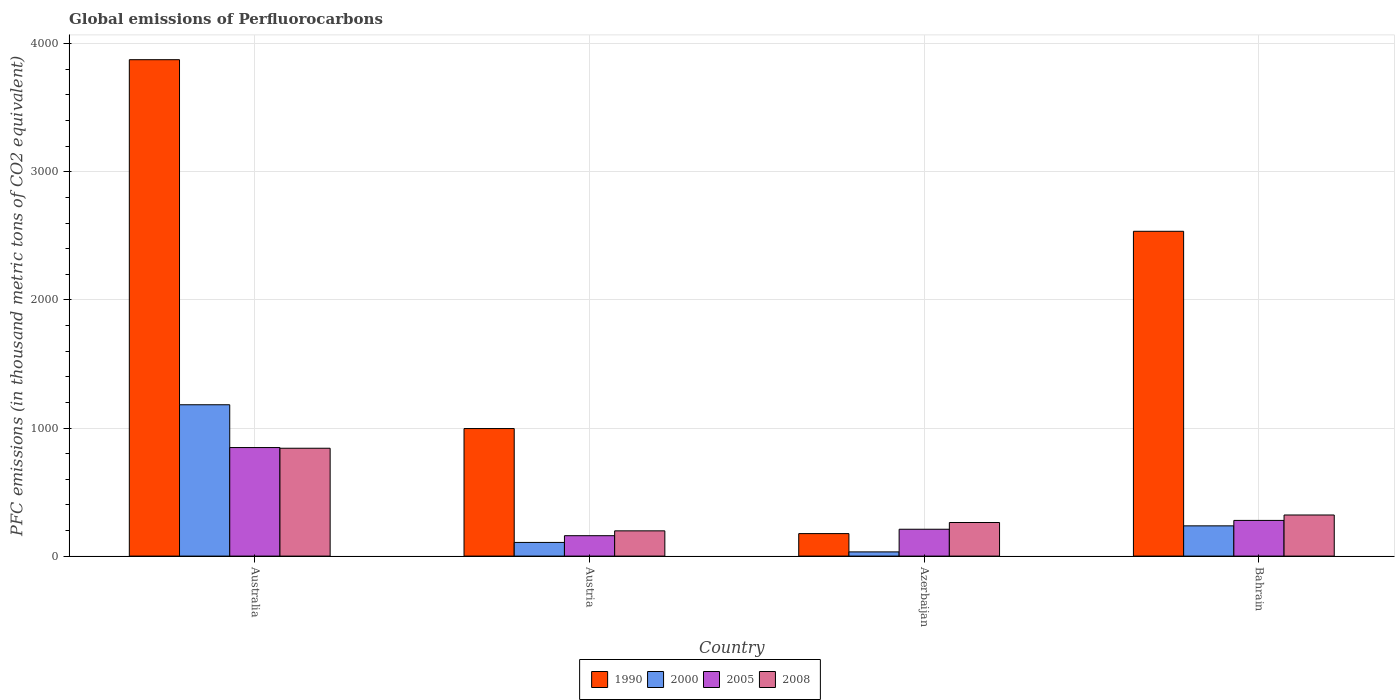How many different coloured bars are there?
Ensure brevity in your answer.  4. What is the label of the 3rd group of bars from the left?
Give a very brief answer. Azerbaijan. What is the global emissions of Perfluorocarbons in 2000 in Austria?
Provide a short and direct response. 106.7. Across all countries, what is the maximum global emissions of Perfluorocarbons in 2008?
Keep it short and to the point. 842. Across all countries, what is the minimum global emissions of Perfluorocarbons in 2005?
Your answer should be very brief. 159.3. In which country was the global emissions of Perfluorocarbons in 1990 minimum?
Your answer should be very brief. Azerbaijan. What is the total global emissions of Perfluorocarbons in 2008 in the graph?
Provide a short and direct response. 1622.2. What is the difference between the global emissions of Perfluorocarbons in 2005 in Azerbaijan and that in Bahrain?
Provide a succinct answer. -68.9. What is the difference between the global emissions of Perfluorocarbons in 2005 in Bahrain and the global emissions of Perfluorocarbons in 2000 in Azerbaijan?
Provide a short and direct response. 245.8. What is the average global emissions of Perfluorocarbons in 2008 per country?
Make the answer very short. 405.55. What is the difference between the global emissions of Perfluorocarbons of/in 2000 and global emissions of Perfluorocarbons of/in 1990 in Azerbaijan?
Your answer should be very brief. -142.8. In how many countries, is the global emissions of Perfluorocarbons in 2008 greater than 1200 thousand metric tons?
Your answer should be compact. 0. What is the ratio of the global emissions of Perfluorocarbons in 2005 in Austria to that in Bahrain?
Make the answer very short. 0.57. Is the global emissions of Perfluorocarbons in 1990 in Australia less than that in Azerbaijan?
Your response must be concise. No. What is the difference between the highest and the second highest global emissions of Perfluorocarbons in 2005?
Provide a short and direct response. -68.9. What is the difference between the highest and the lowest global emissions of Perfluorocarbons in 2005?
Provide a succinct answer. 688.1. In how many countries, is the global emissions of Perfluorocarbons in 1990 greater than the average global emissions of Perfluorocarbons in 1990 taken over all countries?
Your answer should be very brief. 2. What does the 2nd bar from the left in Australia represents?
Offer a very short reply. 2000. What does the 3rd bar from the right in Azerbaijan represents?
Provide a succinct answer. 2000. Is it the case that in every country, the sum of the global emissions of Perfluorocarbons in 2000 and global emissions of Perfluorocarbons in 1990 is greater than the global emissions of Perfluorocarbons in 2005?
Provide a succinct answer. No. How many bars are there?
Offer a terse response. 16. Are all the bars in the graph horizontal?
Offer a very short reply. No. How many countries are there in the graph?
Offer a very short reply. 4. Are the values on the major ticks of Y-axis written in scientific E-notation?
Offer a terse response. No. Does the graph contain any zero values?
Provide a short and direct response. No. Where does the legend appear in the graph?
Ensure brevity in your answer.  Bottom center. What is the title of the graph?
Your answer should be compact. Global emissions of Perfluorocarbons. What is the label or title of the Y-axis?
Offer a terse response. PFC emissions (in thousand metric tons of CO2 equivalent). What is the PFC emissions (in thousand metric tons of CO2 equivalent) in 1990 in Australia?
Offer a terse response. 3875.2. What is the PFC emissions (in thousand metric tons of CO2 equivalent) in 2000 in Australia?
Make the answer very short. 1181.4. What is the PFC emissions (in thousand metric tons of CO2 equivalent) of 2005 in Australia?
Your response must be concise. 847.4. What is the PFC emissions (in thousand metric tons of CO2 equivalent) of 2008 in Australia?
Your answer should be compact. 842. What is the PFC emissions (in thousand metric tons of CO2 equivalent) in 1990 in Austria?
Keep it short and to the point. 995.7. What is the PFC emissions (in thousand metric tons of CO2 equivalent) of 2000 in Austria?
Offer a terse response. 106.7. What is the PFC emissions (in thousand metric tons of CO2 equivalent) of 2005 in Austria?
Provide a short and direct response. 159.3. What is the PFC emissions (in thousand metric tons of CO2 equivalent) of 2008 in Austria?
Keep it short and to the point. 197.1. What is the PFC emissions (in thousand metric tons of CO2 equivalent) of 1990 in Azerbaijan?
Offer a very short reply. 175.6. What is the PFC emissions (in thousand metric tons of CO2 equivalent) in 2000 in Azerbaijan?
Give a very brief answer. 32.8. What is the PFC emissions (in thousand metric tons of CO2 equivalent) of 2005 in Azerbaijan?
Ensure brevity in your answer.  209.7. What is the PFC emissions (in thousand metric tons of CO2 equivalent) of 2008 in Azerbaijan?
Provide a succinct answer. 262.2. What is the PFC emissions (in thousand metric tons of CO2 equivalent) in 1990 in Bahrain?
Keep it short and to the point. 2535.7. What is the PFC emissions (in thousand metric tons of CO2 equivalent) of 2000 in Bahrain?
Give a very brief answer. 236.1. What is the PFC emissions (in thousand metric tons of CO2 equivalent) of 2005 in Bahrain?
Offer a terse response. 278.6. What is the PFC emissions (in thousand metric tons of CO2 equivalent) of 2008 in Bahrain?
Provide a short and direct response. 320.9. Across all countries, what is the maximum PFC emissions (in thousand metric tons of CO2 equivalent) in 1990?
Your answer should be very brief. 3875.2. Across all countries, what is the maximum PFC emissions (in thousand metric tons of CO2 equivalent) of 2000?
Make the answer very short. 1181.4. Across all countries, what is the maximum PFC emissions (in thousand metric tons of CO2 equivalent) of 2005?
Your response must be concise. 847.4. Across all countries, what is the maximum PFC emissions (in thousand metric tons of CO2 equivalent) in 2008?
Offer a terse response. 842. Across all countries, what is the minimum PFC emissions (in thousand metric tons of CO2 equivalent) in 1990?
Make the answer very short. 175.6. Across all countries, what is the minimum PFC emissions (in thousand metric tons of CO2 equivalent) of 2000?
Ensure brevity in your answer.  32.8. Across all countries, what is the minimum PFC emissions (in thousand metric tons of CO2 equivalent) of 2005?
Make the answer very short. 159.3. Across all countries, what is the minimum PFC emissions (in thousand metric tons of CO2 equivalent) in 2008?
Make the answer very short. 197.1. What is the total PFC emissions (in thousand metric tons of CO2 equivalent) in 1990 in the graph?
Ensure brevity in your answer.  7582.2. What is the total PFC emissions (in thousand metric tons of CO2 equivalent) of 2000 in the graph?
Provide a succinct answer. 1557. What is the total PFC emissions (in thousand metric tons of CO2 equivalent) of 2005 in the graph?
Offer a very short reply. 1495. What is the total PFC emissions (in thousand metric tons of CO2 equivalent) of 2008 in the graph?
Your answer should be very brief. 1622.2. What is the difference between the PFC emissions (in thousand metric tons of CO2 equivalent) in 1990 in Australia and that in Austria?
Offer a very short reply. 2879.5. What is the difference between the PFC emissions (in thousand metric tons of CO2 equivalent) of 2000 in Australia and that in Austria?
Give a very brief answer. 1074.7. What is the difference between the PFC emissions (in thousand metric tons of CO2 equivalent) of 2005 in Australia and that in Austria?
Ensure brevity in your answer.  688.1. What is the difference between the PFC emissions (in thousand metric tons of CO2 equivalent) of 2008 in Australia and that in Austria?
Offer a very short reply. 644.9. What is the difference between the PFC emissions (in thousand metric tons of CO2 equivalent) of 1990 in Australia and that in Azerbaijan?
Ensure brevity in your answer.  3699.6. What is the difference between the PFC emissions (in thousand metric tons of CO2 equivalent) in 2000 in Australia and that in Azerbaijan?
Your answer should be compact. 1148.6. What is the difference between the PFC emissions (in thousand metric tons of CO2 equivalent) in 2005 in Australia and that in Azerbaijan?
Your answer should be compact. 637.7. What is the difference between the PFC emissions (in thousand metric tons of CO2 equivalent) of 2008 in Australia and that in Azerbaijan?
Give a very brief answer. 579.8. What is the difference between the PFC emissions (in thousand metric tons of CO2 equivalent) in 1990 in Australia and that in Bahrain?
Your answer should be very brief. 1339.5. What is the difference between the PFC emissions (in thousand metric tons of CO2 equivalent) in 2000 in Australia and that in Bahrain?
Give a very brief answer. 945.3. What is the difference between the PFC emissions (in thousand metric tons of CO2 equivalent) in 2005 in Australia and that in Bahrain?
Offer a terse response. 568.8. What is the difference between the PFC emissions (in thousand metric tons of CO2 equivalent) of 2008 in Australia and that in Bahrain?
Provide a short and direct response. 521.1. What is the difference between the PFC emissions (in thousand metric tons of CO2 equivalent) of 1990 in Austria and that in Azerbaijan?
Your response must be concise. 820.1. What is the difference between the PFC emissions (in thousand metric tons of CO2 equivalent) of 2000 in Austria and that in Azerbaijan?
Your response must be concise. 73.9. What is the difference between the PFC emissions (in thousand metric tons of CO2 equivalent) in 2005 in Austria and that in Azerbaijan?
Keep it short and to the point. -50.4. What is the difference between the PFC emissions (in thousand metric tons of CO2 equivalent) in 2008 in Austria and that in Azerbaijan?
Offer a terse response. -65.1. What is the difference between the PFC emissions (in thousand metric tons of CO2 equivalent) of 1990 in Austria and that in Bahrain?
Ensure brevity in your answer.  -1540. What is the difference between the PFC emissions (in thousand metric tons of CO2 equivalent) in 2000 in Austria and that in Bahrain?
Your answer should be very brief. -129.4. What is the difference between the PFC emissions (in thousand metric tons of CO2 equivalent) in 2005 in Austria and that in Bahrain?
Provide a short and direct response. -119.3. What is the difference between the PFC emissions (in thousand metric tons of CO2 equivalent) of 2008 in Austria and that in Bahrain?
Your answer should be very brief. -123.8. What is the difference between the PFC emissions (in thousand metric tons of CO2 equivalent) of 1990 in Azerbaijan and that in Bahrain?
Provide a short and direct response. -2360.1. What is the difference between the PFC emissions (in thousand metric tons of CO2 equivalent) of 2000 in Azerbaijan and that in Bahrain?
Give a very brief answer. -203.3. What is the difference between the PFC emissions (in thousand metric tons of CO2 equivalent) in 2005 in Azerbaijan and that in Bahrain?
Keep it short and to the point. -68.9. What is the difference between the PFC emissions (in thousand metric tons of CO2 equivalent) in 2008 in Azerbaijan and that in Bahrain?
Keep it short and to the point. -58.7. What is the difference between the PFC emissions (in thousand metric tons of CO2 equivalent) in 1990 in Australia and the PFC emissions (in thousand metric tons of CO2 equivalent) in 2000 in Austria?
Your response must be concise. 3768.5. What is the difference between the PFC emissions (in thousand metric tons of CO2 equivalent) in 1990 in Australia and the PFC emissions (in thousand metric tons of CO2 equivalent) in 2005 in Austria?
Your response must be concise. 3715.9. What is the difference between the PFC emissions (in thousand metric tons of CO2 equivalent) of 1990 in Australia and the PFC emissions (in thousand metric tons of CO2 equivalent) of 2008 in Austria?
Offer a terse response. 3678.1. What is the difference between the PFC emissions (in thousand metric tons of CO2 equivalent) of 2000 in Australia and the PFC emissions (in thousand metric tons of CO2 equivalent) of 2005 in Austria?
Your answer should be very brief. 1022.1. What is the difference between the PFC emissions (in thousand metric tons of CO2 equivalent) in 2000 in Australia and the PFC emissions (in thousand metric tons of CO2 equivalent) in 2008 in Austria?
Your answer should be compact. 984.3. What is the difference between the PFC emissions (in thousand metric tons of CO2 equivalent) of 2005 in Australia and the PFC emissions (in thousand metric tons of CO2 equivalent) of 2008 in Austria?
Keep it short and to the point. 650.3. What is the difference between the PFC emissions (in thousand metric tons of CO2 equivalent) of 1990 in Australia and the PFC emissions (in thousand metric tons of CO2 equivalent) of 2000 in Azerbaijan?
Offer a very short reply. 3842.4. What is the difference between the PFC emissions (in thousand metric tons of CO2 equivalent) in 1990 in Australia and the PFC emissions (in thousand metric tons of CO2 equivalent) in 2005 in Azerbaijan?
Your response must be concise. 3665.5. What is the difference between the PFC emissions (in thousand metric tons of CO2 equivalent) of 1990 in Australia and the PFC emissions (in thousand metric tons of CO2 equivalent) of 2008 in Azerbaijan?
Keep it short and to the point. 3613. What is the difference between the PFC emissions (in thousand metric tons of CO2 equivalent) of 2000 in Australia and the PFC emissions (in thousand metric tons of CO2 equivalent) of 2005 in Azerbaijan?
Your answer should be compact. 971.7. What is the difference between the PFC emissions (in thousand metric tons of CO2 equivalent) of 2000 in Australia and the PFC emissions (in thousand metric tons of CO2 equivalent) of 2008 in Azerbaijan?
Provide a succinct answer. 919.2. What is the difference between the PFC emissions (in thousand metric tons of CO2 equivalent) in 2005 in Australia and the PFC emissions (in thousand metric tons of CO2 equivalent) in 2008 in Azerbaijan?
Make the answer very short. 585.2. What is the difference between the PFC emissions (in thousand metric tons of CO2 equivalent) in 1990 in Australia and the PFC emissions (in thousand metric tons of CO2 equivalent) in 2000 in Bahrain?
Your response must be concise. 3639.1. What is the difference between the PFC emissions (in thousand metric tons of CO2 equivalent) in 1990 in Australia and the PFC emissions (in thousand metric tons of CO2 equivalent) in 2005 in Bahrain?
Offer a terse response. 3596.6. What is the difference between the PFC emissions (in thousand metric tons of CO2 equivalent) in 1990 in Australia and the PFC emissions (in thousand metric tons of CO2 equivalent) in 2008 in Bahrain?
Give a very brief answer. 3554.3. What is the difference between the PFC emissions (in thousand metric tons of CO2 equivalent) in 2000 in Australia and the PFC emissions (in thousand metric tons of CO2 equivalent) in 2005 in Bahrain?
Give a very brief answer. 902.8. What is the difference between the PFC emissions (in thousand metric tons of CO2 equivalent) in 2000 in Australia and the PFC emissions (in thousand metric tons of CO2 equivalent) in 2008 in Bahrain?
Provide a succinct answer. 860.5. What is the difference between the PFC emissions (in thousand metric tons of CO2 equivalent) in 2005 in Australia and the PFC emissions (in thousand metric tons of CO2 equivalent) in 2008 in Bahrain?
Your answer should be very brief. 526.5. What is the difference between the PFC emissions (in thousand metric tons of CO2 equivalent) in 1990 in Austria and the PFC emissions (in thousand metric tons of CO2 equivalent) in 2000 in Azerbaijan?
Offer a very short reply. 962.9. What is the difference between the PFC emissions (in thousand metric tons of CO2 equivalent) in 1990 in Austria and the PFC emissions (in thousand metric tons of CO2 equivalent) in 2005 in Azerbaijan?
Offer a terse response. 786. What is the difference between the PFC emissions (in thousand metric tons of CO2 equivalent) of 1990 in Austria and the PFC emissions (in thousand metric tons of CO2 equivalent) of 2008 in Azerbaijan?
Provide a short and direct response. 733.5. What is the difference between the PFC emissions (in thousand metric tons of CO2 equivalent) of 2000 in Austria and the PFC emissions (in thousand metric tons of CO2 equivalent) of 2005 in Azerbaijan?
Provide a succinct answer. -103. What is the difference between the PFC emissions (in thousand metric tons of CO2 equivalent) of 2000 in Austria and the PFC emissions (in thousand metric tons of CO2 equivalent) of 2008 in Azerbaijan?
Ensure brevity in your answer.  -155.5. What is the difference between the PFC emissions (in thousand metric tons of CO2 equivalent) in 2005 in Austria and the PFC emissions (in thousand metric tons of CO2 equivalent) in 2008 in Azerbaijan?
Offer a very short reply. -102.9. What is the difference between the PFC emissions (in thousand metric tons of CO2 equivalent) of 1990 in Austria and the PFC emissions (in thousand metric tons of CO2 equivalent) of 2000 in Bahrain?
Offer a terse response. 759.6. What is the difference between the PFC emissions (in thousand metric tons of CO2 equivalent) in 1990 in Austria and the PFC emissions (in thousand metric tons of CO2 equivalent) in 2005 in Bahrain?
Give a very brief answer. 717.1. What is the difference between the PFC emissions (in thousand metric tons of CO2 equivalent) of 1990 in Austria and the PFC emissions (in thousand metric tons of CO2 equivalent) of 2008 in Bahrain?
Ensure brevity in your answer.  674.8. What is the difference between the PFC emissions (in thousand metric tons of CO2 equivalent) in 2000 in Austria and the PFC emissions (in thousand metric tons of CO2 equivalent) in 2005 in Bahrain?
Your response must be concise. -171.9. What is the difference between the PFC emissions (in thousand metric tons of CO2 equivalent) of 2000 in Austria and the PFC emissions (in thousand metric tons of CO2 equivalent) of 2008 in Bahrain?
Your answer should be compact. -214.2. What is the difference between the PFC emissions (in thousand metric tons of CO2 equivalent) in 2005 in Austria and the PFC emissions (in thousand metric tons of CO2 equivalent) in 2008 in Bahrain?
Provide a succinct answer. -161.6. What is the difference between the PFC emissions (in thousand metric tons of CO2 equivalent) in 1990 in Azerbaijan and the PFC emissions (in thousand metric tons of CO2 equivalent) in 2000 in Bahrain?
Your answer should be compact. -60.5. What is the difference between the PFC emissions (in thousand metric tons of CO2 equivalent) in 1990 in Azerbaijan and the PFC emissions (in thousand metric tons of CO2 equivalent) in 2005 in Bahrain?
Ensure brevity in your answer.  -103. What is the difference between the PFC emissions (in thousand metric tons of CO2 equivalent) in 1990 in Azerbaijan and the PFC emissions (in thousand metric tons of CO2 equivalent) in 2008 in Bahrain?
Give a very brief answer. -145.3. What is the difference between the PFC emissions (in thousand metric tons of CO2 equivalent) in 2000 in Azerbaijan and the PFC emissions (in thousand metric tons of CO2 equivalent) in 2005 in Bahrain?
Offer a very short reply. -245.8. What is the difference between the PFC emissions (in thousand metric tons of CO2 equivalent) of 2000 in Azerbaijan and the PFC emissions (in thousand metric tons of CO2 equivalent) of 2008 in Bahrain?
Provide a short and direct response. -288.1. What is the difference between the PFC emissions (in thousand metric tons of CO2 equivalent) in 2005 in Azerbaijan and the PFC emissions (in thousand metric tons of CO2 equivalent) in 2008 in Bahrain?
Keep it short and to the point. -111.2. What is the average PFC emissions (in thousand metric tons of CO2 equivalent) of 1990 per country?
Keep it short and to the point. 1895.55. What is the average PFC emissions (in thousand metric tons of CO2 equivalent) in 2000 per country?
Your response must be concise. 389.25. What is the average PFC emissions (in thousand metric tons of CO2 equivalent) in 2005 per country?
Your response must be concise. 373.75. What is the average PFC emissions (in thousand metric tons of CO2 equivalent) in 2008 per country?
Provide a short and direct response. 405.55. What is the difference between the PFC emissions (in thousand metric tons of CO2 equivalent) in 1990 and PFC emissions (in thousand metric tons of CO2 equivalent) in 2000 in Australia?
Keep it short and to the point. 2693.8. What is the difference between the PFC emissions (in thousand metric tons of CO2 equivalent) in 1990 and PFC emissions (in thousand metric tons of CO2 equivalent) in 2005 in Australia?
Your answer should be very brief. 3027.8. What is the difference between the PFC emissions (in thousand metric tons of CO2 equivalent) of 1990 and PFC emissions (in thousand metric tons of CO2 equivalent) of 2008 in Australia?
Provide a succinct answer. 3033.2. What is the difference between the PFC emissions (in thousand metric tons of CO2 equivalent) of 2000 and PFC emissions (in thousand metric tons of CO2 equivalent) of 2005 in Australia?
Your response must be concise. 334. What is the difference between the PFC emissions (in thousand metric tons of CO2 equivalent) in 2000 and PFC emissions (in thousand metric tons of CO2 equivalent) in 2008 in Australia?
Provide a short and direct response. 339.4. What is the difference between the PFC emissions (in thousand metric tons of CO2 equivalent) of 2005 and PFC emissions (in thousand metric tons of CO2 equivalent) of 2008 in Australia?
Make the answer very short. 5.4. What is the difference between the PFC emissions (in thousand metric tons of CO2 equivalent) of 1990 and PFC emissions (in thousand metric tons of CO2 equivalent) of 2000 in Austria?
Give a very brief answer. 889. What is the difference between the PFC emissions (in thousand metric tons of CO2 equivalent) of 1990 and PFC emissions (in thousand metric tons of CO2 equivalent) of 2005 in Austria?
Give a very brief answer. 836.4. What is the difference between the PFC emissions (in thousand metric tons of CO2 equivalent) in 1990 and PFC emissions (in thousand metric tons of CO2 equivalent) in 2008 in Austria?
Your response must be concise. 798.6. What is the difference between the PFC emissions (in thousand metric tons of CO2 equivalent) in 2000 and PFC emissions (in thousand metric tons of CO2 equivalent) in 2005 in Austria?
Your answer should be very brief. -52.6. What is the difference between the PFC emissions (in thousand metric tons of CO2 equivalent) of 2000 and PFC emissions (in thousand metric tons of CO2 equivalent) of 2008 in Austria?
Provide a short and direct response. -90.4. What is the difference between the PFC emissions (in thousand metric tons of CO2 equivalent) of 2005 and PFC emissions (in thousand metric tons of CO2 equivalent) of 2008 in Austria?
Ensure brevity in your answer.  -37.8. What is the difference between the PFC emissions (in thousand metric tons of CO2 equivalent) in 1990 and PFC emissions (in thousand metric tons of CO2 equivalent) in 2000 in Azerbaijan?
Ensure brevity in your answer.  142.8. What is the difference between the PFC emissions (in thousand metric tons of CO2 equivalent) of 1990 and PFC emissions (in thousand metric tons of CO2 equivalent) of 2005 in Azerbaijan?
Offer a very short reply. -34.1. What is the difference between the PFC emissions (in thousand metric tons of CO2 equivalent) in 1990 and PFC emissions (in thousand metric tons of CO2 equivalent) in 2008 in Azerbaijan?
Keep it short and to the point. -86.6. What is the difference between the PFC emissions (in thousand metric tons of CO2 equivalent) of 2000 and PFC emissions (in thousand metric tons of CO2 equivalent) of 2005 in Azerbaijan?
Your answer should be compact. -176.9. What is the difference between the PFC emissions (in thousand metric tons of CO2 equivalent) of 2000 and PFC emissions (in thousand metric tons of CO2 equivalent) of 2008 in Azerbaijan?
Your answer should be very brief. -229.4. What is the difference between the PFC emissions (in thousand metric tons of CO2 equivalent) of 2005 and PFC emissions (in thousand metric tons of CO2 equivalent) of 2008 in Azerbaijan?
Ensure brevity in your answer.  -52.5. What is the difference between the PFC emissions (in thousand metric tons of CO2 equivalent) of 1990 and PFC emissions (in thousand metric tons of CO2 equivalent) of 2000 in Bahrain?
Offer a terse response. 2299.6. What is the difference between the PFC emissions (in thousand metric tons of CO2 equivalent) in 1990 and PFC emissions (in thousand metric tons of CO2 equivalent) in 2005 in Bahrain?
Make the answer very short. 2257.1. What is the difference between the PFC emissions (in thousand metric tons of CO2 equivalent) of 1990 and PFC emissions (in thousand metric tons of CO2 equivalent) of 2008 in Bahrain?
Offer a very short reply. 2214.8. What is the difference between the PFC emissions (in thousand metric tons of CO2 equivalent) of 2000 and PFC emissions (in thousand metric tons of CO2 equivalent) of 2005 in Bahrain?
Offer a very short reply. -42.5. What is the difference between the PFC emissions (in thousand metric tons of CO2 equivalent) of 2000 and PFC emissions (in thousand metric tons of CO2 equivalent) of 2008 in Bahrain?
Your answer should be very brief. -84.8. What is the difference between the PFC emissions (in thousand metric tons of CO2 equivalent) in 2005 and PFC emissions (in thousand metric tons of CO2 equivalent) in 2008 in Bahrain?
Your answer should be compact. -42.3. What is the ratio of the PFC emissions (in thousand metric tons of CO2 equivalent) of 1990 in Australia to that in Austria?
Offer a terse response. 3.89. What is the ratio of the PFC emissions (in thousand metric tons of CO2 equivalent) of 2000 in Australia to that in Austria?
Offer a very short reply. 11.07. What is the ratio of the PFC emissions (in thousand metric tons of CO2 equivalent) of 2005 in Australia to that in Austria?
Your answer should be compact. 5.32. What is the ratio of the PFC emissions (in thousand metric tons of CO2 equivalent) of 2008 in Australia to that in Austria?
Give a very brief answer. 4.27. What is the ratio of the PFC emissions (in thousand metric tons of CO2 equivalent) in 1990 in Australia to that in Azerbaijan?
Offer a terse response. 22.07. What is the ratio of the PFC emissions (in thousand metric tons of CO2 equivalent) of 2000 in Australia to that in Azerbaijan?
Ensure brevity in your answer.  36.02. What is the ratio of the PFC emissions (in thousand metric tons of CO2 equivalent) of 2005 in Australia to that in Azerbaijan?
Offer a terse response. 4.04. What is the ratio of the PFC emissions (in thousand metric tons of CO2 equivalent) in 2008 in Australia to that in Azerbaijan?
Keep it short and to the point. 3.21. What is the ratio of the PFC emissions (in thousand metric tons of CO2 equivalent) of 1990 in Australia to that in Bahrain?
Make the answer very short. 1.53. What is the ratio of the PFC emissions (in thousand metric tons of CO2 equivalent) of 2000 in Australia to that in Bahrain?
Make the answer very short. 5. What is the ratio of the PFC emissions (in thousand metric tons of CO2 equivalent) of 2005 in Australia to that in Bahrain?
Make the answer very short. 3.04. What is the ratio of the PFC emissions (in thousand metric tons of CO2 equivalent) of 2008 in Australia to that in Bahrain?
Keep it short and to the point. 2.62. What is the ratio of the PFC emissions (in thousand metric tons of CO2 equivalent) of 1990 in Austria to that in Azerbaijan?
Make the answer very short. 5.67. What is the ratio of the PFC emissions (in thousand metric tons of CO2 equivalent) of 2000 in Austria to that in Azerbaijan?
Your answer should be very brief. 3.25. What is the ratio of the PFC emissions (in thousand metric tons of CO2 equivalent) in 2005 in Austria to that in Azerbaijan?
Provide a succinct answer. 0.76. What is the ratio of the PFC emissions (in thousand metric tons of CO2 equivalent) in 2008 in Austria to that in Azerbaijan?
Keep it short and to the point. 0.75. What is the ratio of the PFC emissions (in thousand metric tons of CO2 equivalent) of 1990 in Austria to that in Bahrain?
Ensure brevity in your answer.  0.39. What is the ratio of the PFC emissions (in thousand metric tons of CO2 equivalent) in 2000 in Austria to that in Bahrain?
Offer a terse response. 0.45. What is the ratio of the PFC emissions (in thousand metric tons of CO2 equivalent) in 2005 in Austria to that in Bahrain?
Provide a short and direct response. 0.57. What is the ratio of the PFC emissions (in thousand metric tons of CO2 equivalent) in 2008 in Austria to that in Bahrain?
Ensure brevity in your answer.  0.61. What is the ratio of the PFC emissions (in thousand metric tons of CO2 equivalent) in 1990 in Azerbaijan to that in Bahrain?
Offer a terse response. 0.07. What is the ratio of the PFC emissions (in thousand metric tons of CO2 equivalent) in 2000 in Azerbaijan to that in Bahrain?
Your answer should be compact. 0.14. What is the ratio of the PFC emissions (in thousand metric tons of CO2 equivalent) of 2005 in Azerbaijan to that in Bahrain?
Your response must be concise. 0.75. What is the ratio of the PFC emissions (in thousand metric tons of CO2 equivalent) in 2008 in Azerbaijan to that in Bahrain?
Ensure brevity in your answer.  0.82. What is the difference between the highest and the second highest PFC emissions (in thousand metric tons of CO2 equivalent) of 1990?
Your response must be concise. 1339.5. What is the difference between the highest and the second highest PFC emissions (in thousand metric tons of CO2 equivalent) in 2000?
Give a very brief answer. 945.3. What is the difference between the highest and the second highest PFC emissions (in thousand metric tons of CO2 equivalent) of 2005?
Give a very brief answer. 568.8. What is the difference between the highest and the second highest PFC emissions (in thousand metric tons of CO2 equivalent) of 2008?
Make the answer very short. 521.1. What is the difference between the highest and the lowest PFC emissions (in thousand metric tons of CO2 equivalent) in 1990?
Make the answer very short. 3699.6. What is the difference between the highest and the lowest PFC emissions (in thousand metric tons of CO2 equivalent) in 2000?
Provide a succinct answer. 1148.6. What is the difference between the highest and the lowest PFC emissions (in thousand metric tons of CO2 equivalent) in 2005?
Make the answer very short. 688.1. What is the difference between the highest and the lowest PFC emissions (in thousand metric tons of CO2 equivalent) in 2008?
Make the answer very short. 644.9. 